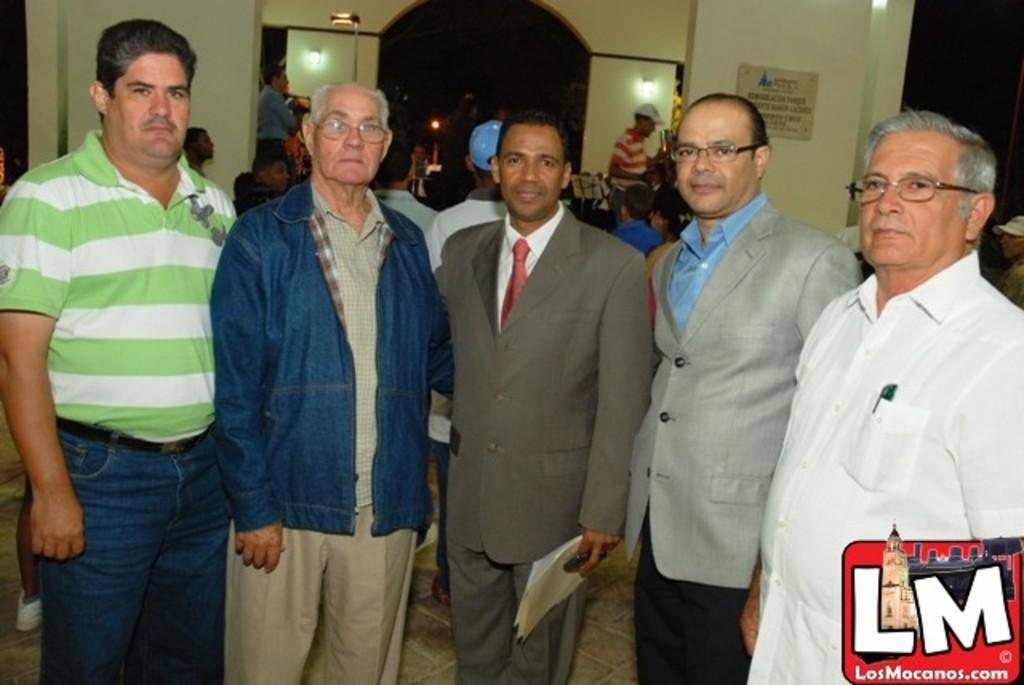Please provide a concise description of this image. In this image I can see number of people are standing. In the front I can see three of them are wearing specs and in the center I can see one of them is holding few papers and a black colour thing. In the background I can see a board, few lights and on the board I can see something is written. On the bottom right side of this image I can see a watermark. 